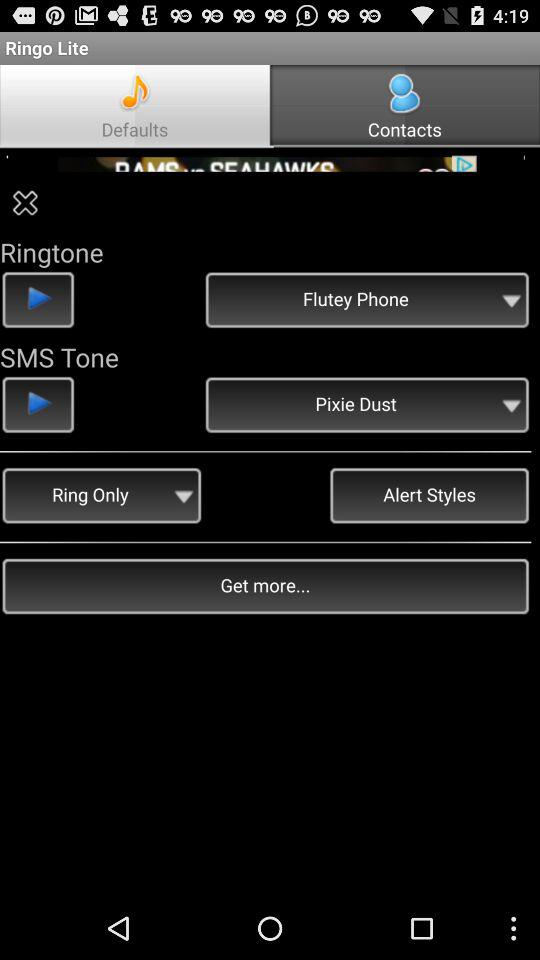What is the selected SMS tone? The selected SMS tone is "Pixie Dust". 